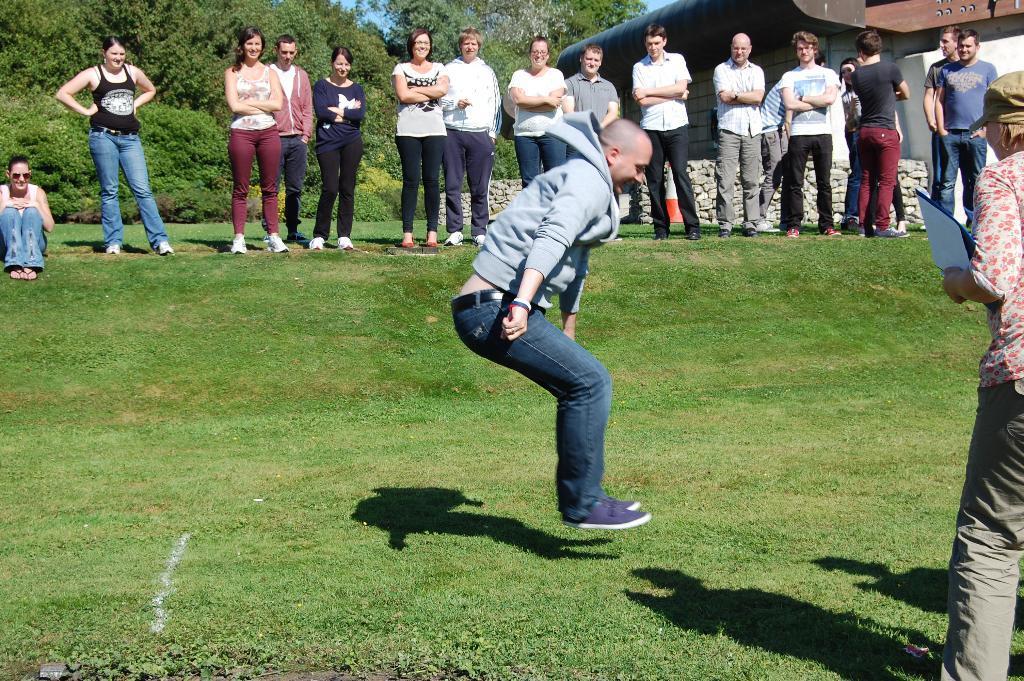In one or two sentences, can you explain what this image depicts? In this picture I can see few people are standing and a human holding a file in the hand and I can see another man jumping and I can see a woman seated and I can see few trees and grass on the ground and a building on the top right corner. 